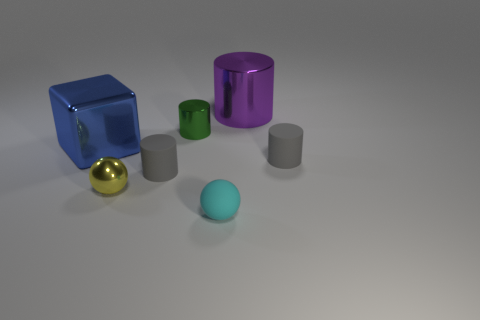Are there any other things that have the same shape as the blue object?
Offer a very short reply. No. What is the shape of the tiny gray rubber thing on the left side of the green cylinder?
Offer a terse response. Cylinder. What number of other things are the same material as the purple thing?
Keep it short and to the point. 3. What is the material of the purple object?
Your answer should be compact. Metal. What number of large things are purple rubber cubes or cyan spheres?
Give a very brief answer. 0. How many small green shiny things are on the left side of the green shiny object?
Give a very brief answer. 0. Is there another small ball that has the same color as the small rubber ball?
Your answer should be compact. No. The thing that is the same size as the purple metal cylinder is what shape?
Provide a succinct answer. Cube. How many blue objects are either matte spheres or small metal spheres?
Your answer should be very brief. 0. What number of gray things are the same size as the cyan rubber sphere?
Provide a succinct answer. 2. 